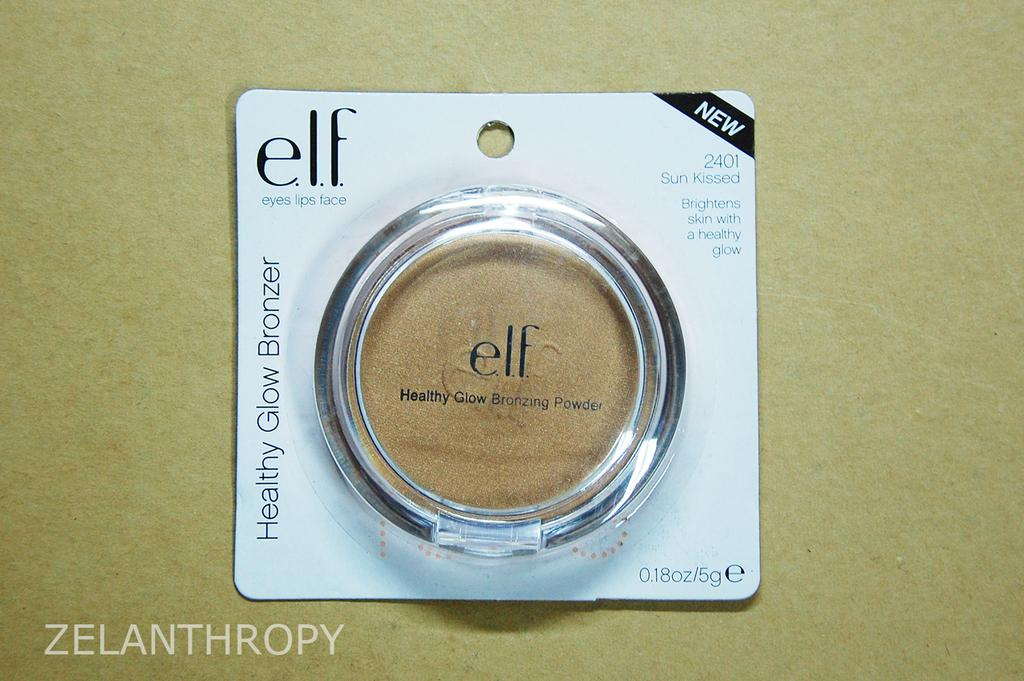<image>
Give a short and clear explanation of the subsequent image. a package of elf cosmetics is unopened and on a table 